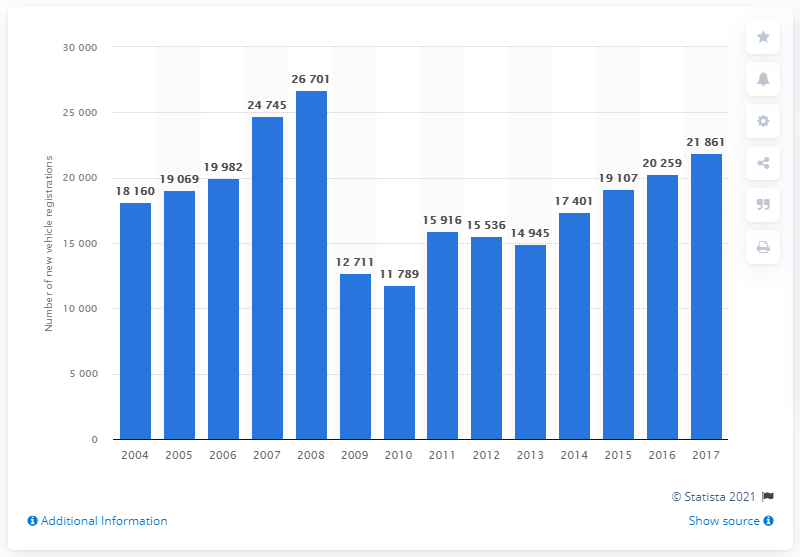Specify some key components in this picture. In 2008 and 2009, a total of 26,701 new semi-trailers were registered. In 2017, a total of 21,861 semi-trailers were registered in France. 